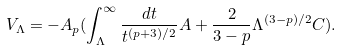<formula> <loc_0><loc_0><loc_500><loc_500>V _ { \Lambda } = - A _ { p } ( \int _ { \Lambda } ^ { \infty } \frac { d t } { t ^ { ( p + 3 ) / 2 } } A + \frac { 2 } { 3 - p } \Lambda ^ { ( 3 - p ) / 2 } C ) .</formula> 